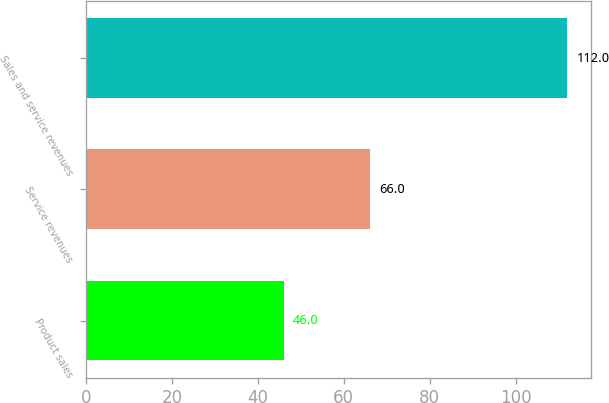Convert chart. <chart><loc_0><loc_0><loc_500><loc_500><bar_chart><fcel>Product sales<fcel>Service revenues<fcel>Sales and service revenues<nl><fcel>46<fcel>66<fcel>112<nl></chart> 